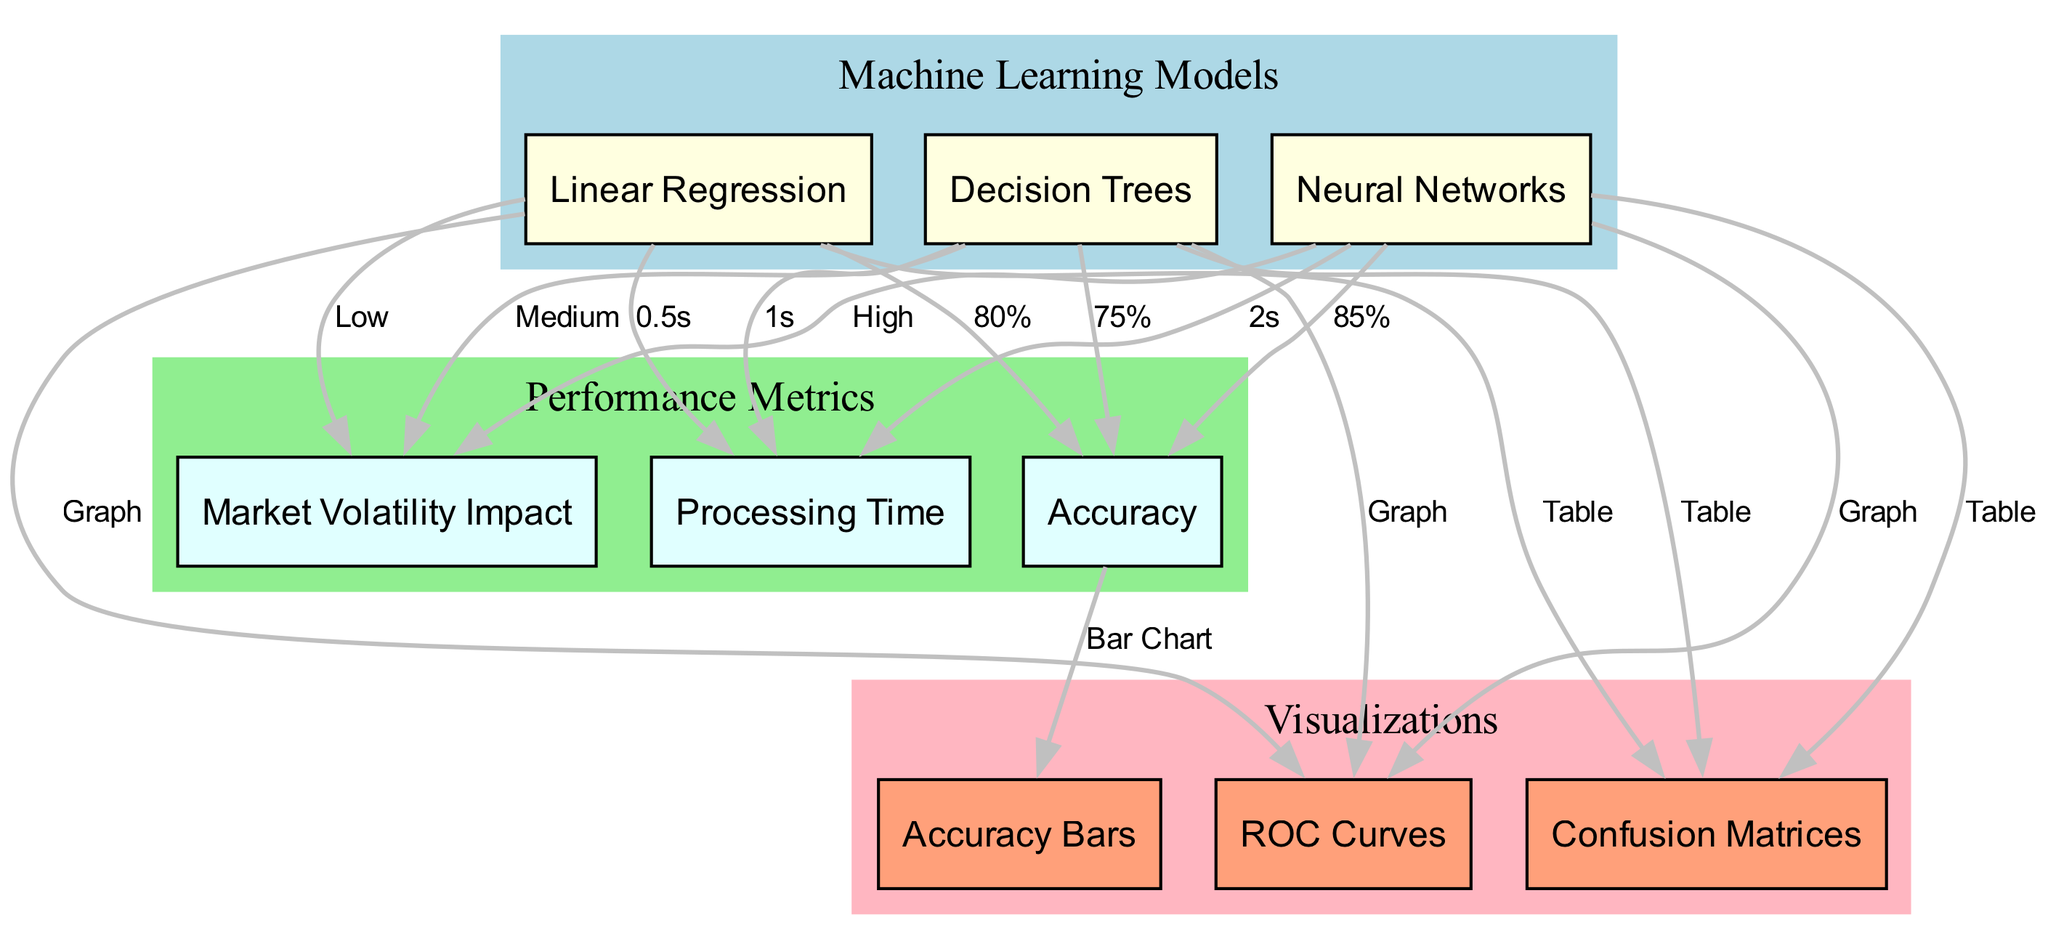What is the accuracy of neural networks? The diagram indicates that neural networks achieve an accuracy of 85%, as shown by the edge connecting the 'neural networks' node to the 'accuracy' node labeled with this percentage.
Answer: 85% What is the processing time for linear regression? The processing time for linear regression is represented as 0.5 seconds, indicated by the edge from the 'linear regression' node to the 'processing time' node with the corresponding label.
Answer: 0.5s Which model has the highest impact on market volatility? By examining the relationships in the diagram, it is clear that neural networks have a 'High' impact on market volatility, as indicated by the edge connecting the 'neural networks' node to the 'market volatility impact' node labeled 'High'.
Answer: High How many models are represented in the diagram? The diagram features three models: linear regression, neural networks, and decision trees, which can be counted in the 'Machine Learning Models' section.
Answer: 3 What type of visual representation is used to illustrate accuracy? The accuracy is depicted as a bar chart, as indicated by the edge from the 'accuracy' node pointing to the 'accuracy bars' node, labeled 'Bar Chart'.
Answer: Bar Chart What is the accuracy of decision trees? It can be determined from the diagram that decision trees have an accuracy of 75%, as indicated by the edge connecting the 'decision trees' node to the 'accuracy' node labeled with this value.
Answer: 75% How does the processing time of decision trees compare to neural networks? By comparing the processing time nodes, decision trees have a processing time of 1 second, while neural networks take 2 seconds. This reveals that decision trees are faster than neural networks by 1 second.
Answer: Faster by 1 second What is the common type of visualization for the models? The common type of visualization shown in the diagram for all models is a confusion matrix, as indicated by the edges pointing from each model node to the 'confusion matrix' node labeled 'Table'.
Answer: Table What accuracy percentage does linear regression have? The diagram specifies that linear regression has an accuracy of 80%, clearly labeled on the edge connecting 'linear_regression' to 'accuracy'.
Answer: 80% 